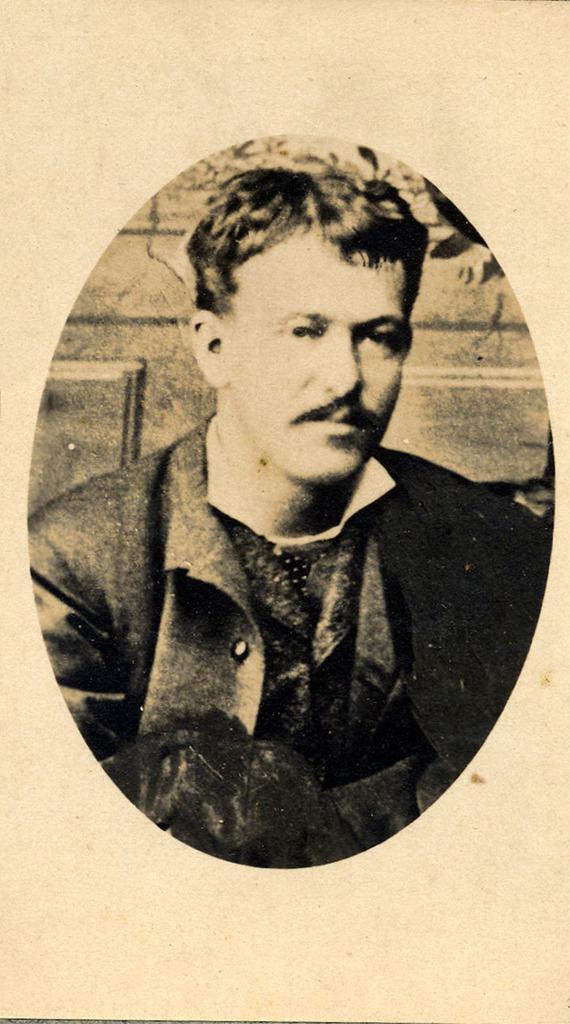Can you describe this image briefly? In the image we can see the poster, in the poster we can see a photo of a man wearing clothes. 